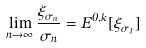Convert formula to latex. <formula><loc_0><loc_0><loc_500><loc_500>\lim _ { n \to \infty } \frac { \xi _ { \sigma _ { n } } } { \sigma _ { n } } = E ^ { 0 , k } [ \xi _ { \sigma _ { 1 } } ]</formula> 